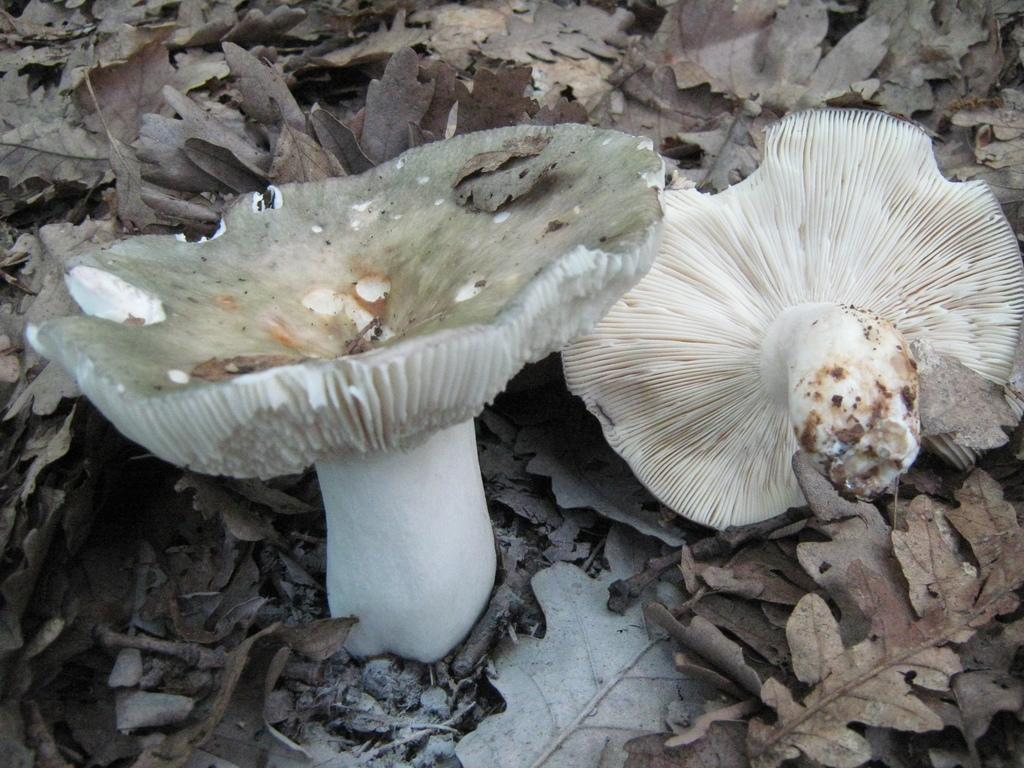What type of fungi can be seen in the image? There are mushrooms in the image. What type of plant material is also present in the image? There are dried leaves in the image. Where are the mushrooms and dried leaves located? Both the mushrooms and dried leaves are on the ground. What direction does the minister turn when walking downtown in the image? There is no minister or downtown location present in the image; it only features mushrooms and dried leaves on the ground. 